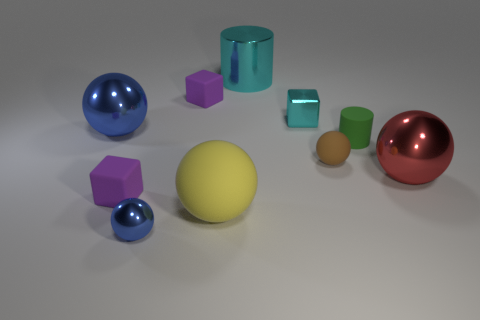Subtract all brown spheres. How many spheres are left? 4 Subtract all large blue balls. How many balls are left? 4 Subtract all cyan spheres. Subtract all brown cylinders. How many spheres are left? 5 Subtract all blocks. How many objects are left? 7 Add 1 large yellow blocks. How many large yellow blocks exist? 1 Subtract 0 yellow cylinders. How many objects are left? 10 Subtract all tiny yellow cubes. Subtract all small green cylinders. How many objects are left? 9 Add 1 tiny purple matte objects. How many tiny purple matte objects are left? 3 